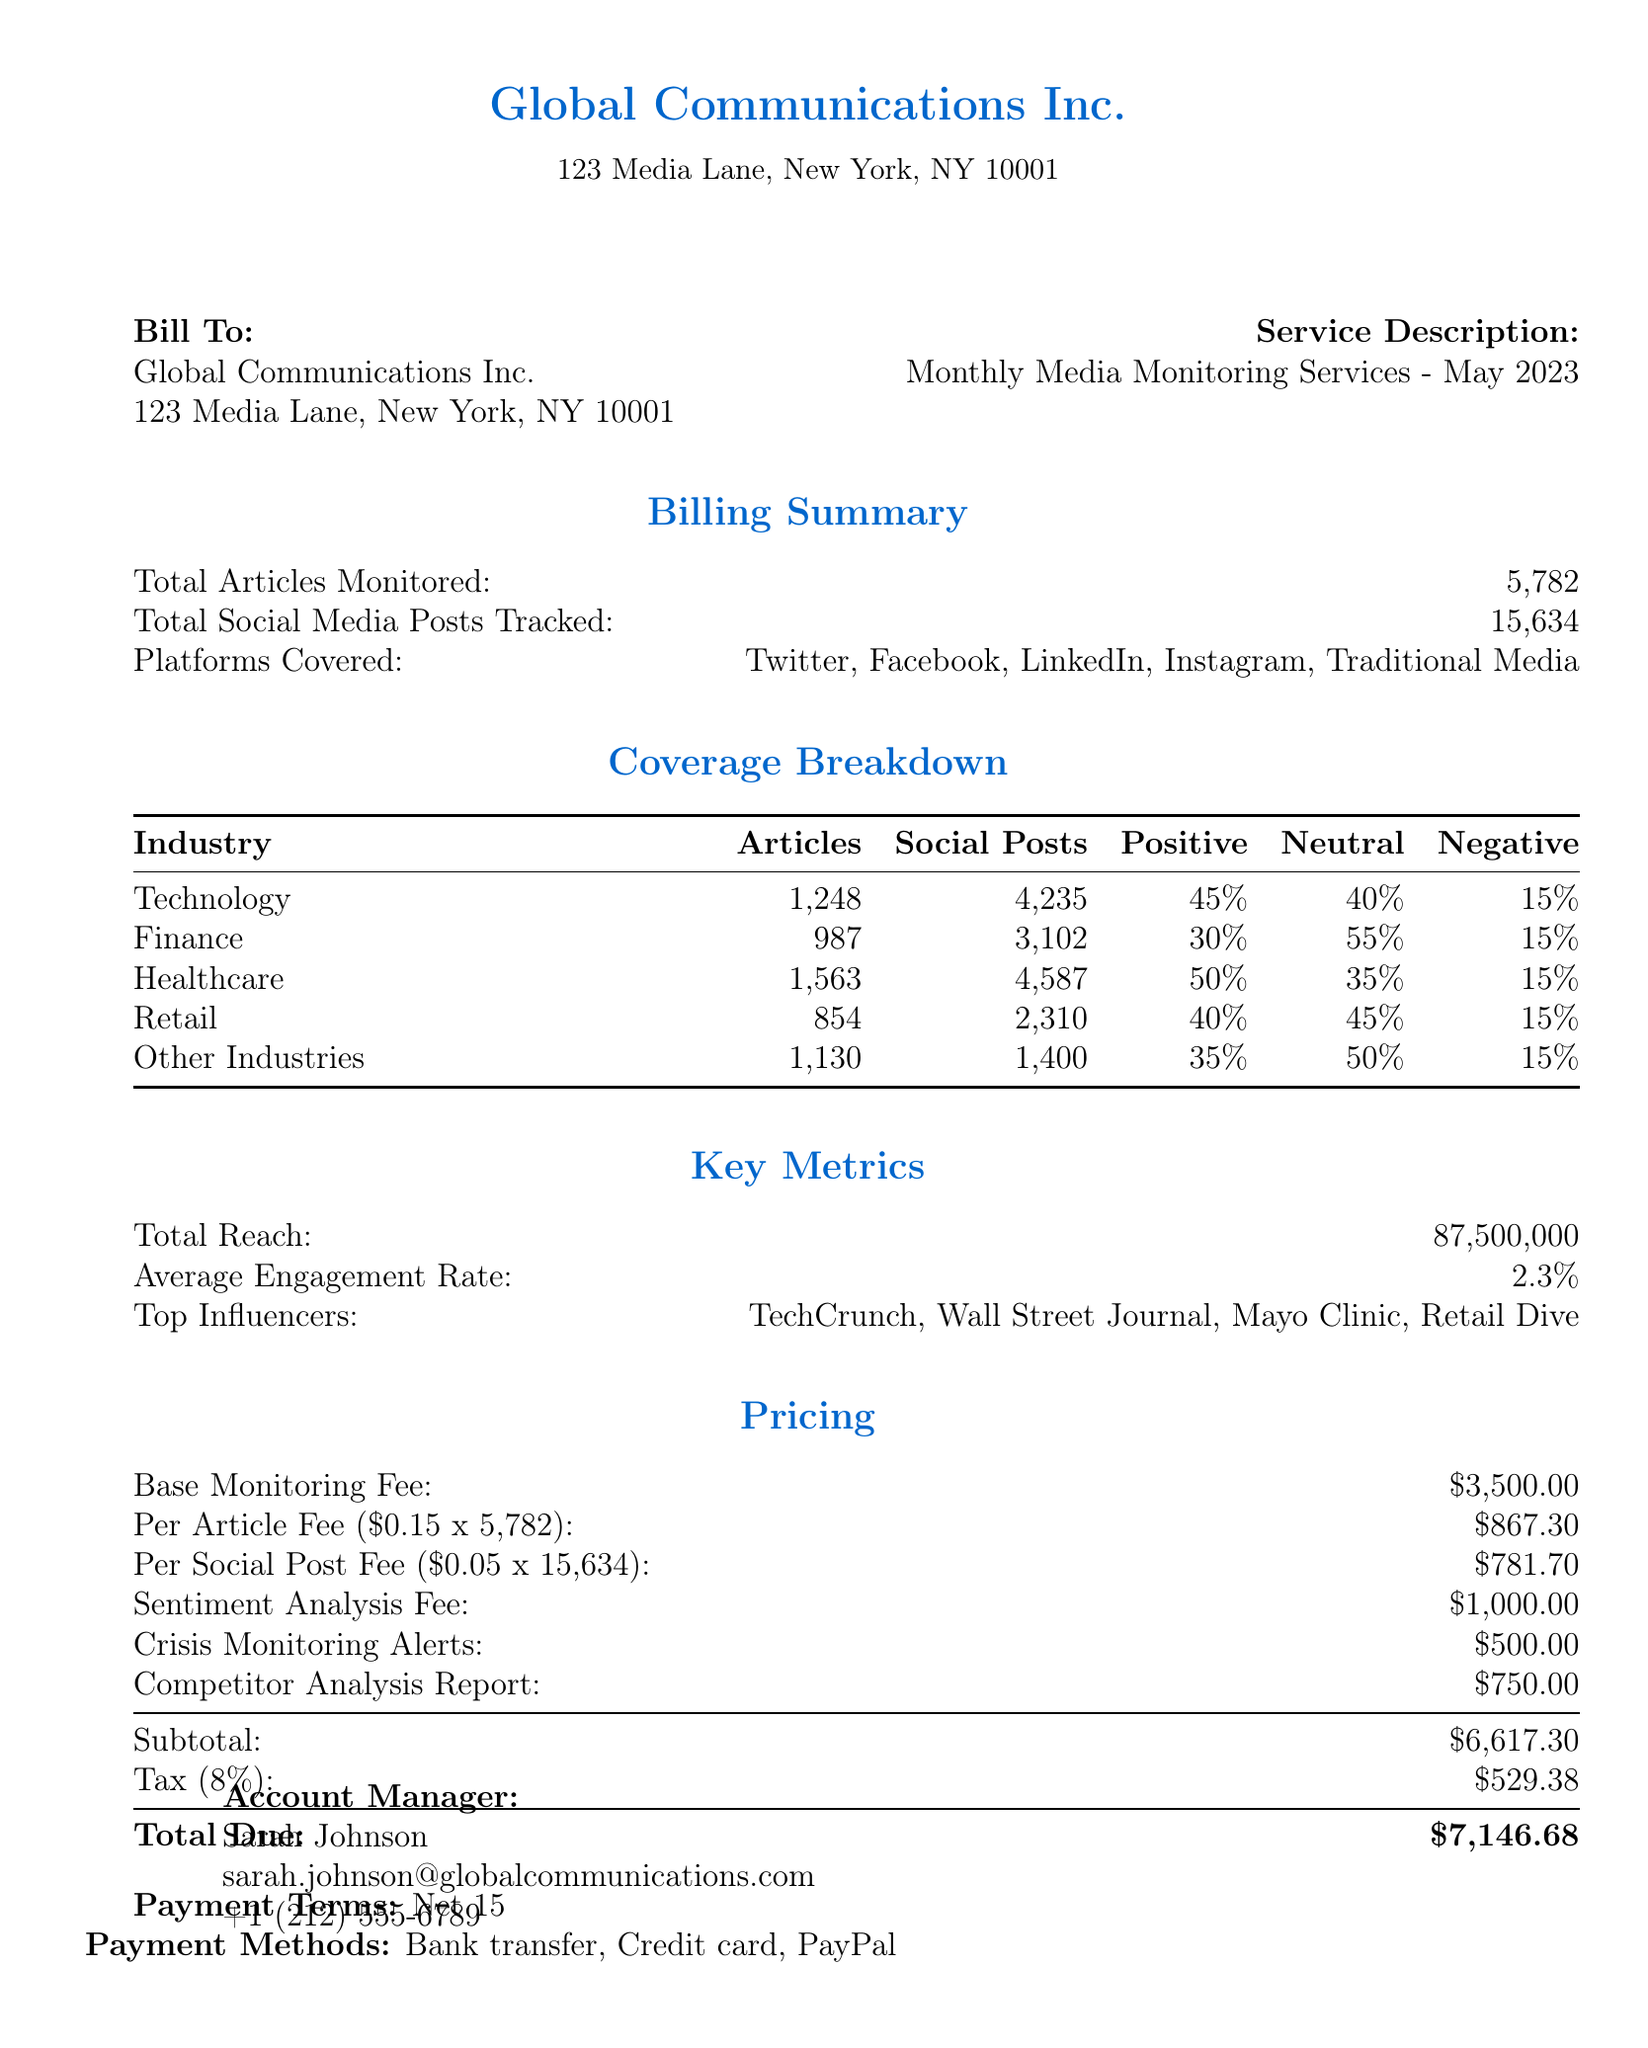what is the invoice number? The invoice number is listed in the document as a specific identifier for the billing, which is INV-2023-05-001.
Answer: INV-2023-05-001 what is the total number of articles monitored? The total number of articles monitored is provided in the billing summary section, indicating the extent of media monitoring services.
Answer: 5,782 what is the positive sentiment percentage for the healthcare industry? The healthcare industry's sentiment analysis indicates the proportion of positive sentiments collected, which is detailed in the coverage breakdown.
Answer: 50% how many platforms are covered for media monitoring? The document lists the number of different platforms where media monitoring took place, which helps understand the reach of the services provided.
Answer: 5 what is the total amount due? The total amount due is calculated after summing the subtotal and tax, representing the final billing for the month.
Answer: $7,146.68 who is the account manager? The document provides the name of the account manager, which is important for client communication regarding the invoice.
Answer: Sarah Johnson what is included in the additional services total? The additional services total comprises the costs of crisis monitoring alerts and the competitor analysis report, which are specified items in the pricing section.
Answer: $1,250 what is the average engagement rate? The engagement rate indicates the effectiveness of media coverage and is a crucial metric provided in the key metrics section.
Answer: 2.3% when is the invoice due date? The due date indicates when the payment must be made to avoid penalties, and it is specified clearly in the invoice details.
Answer: 2023-06-15 